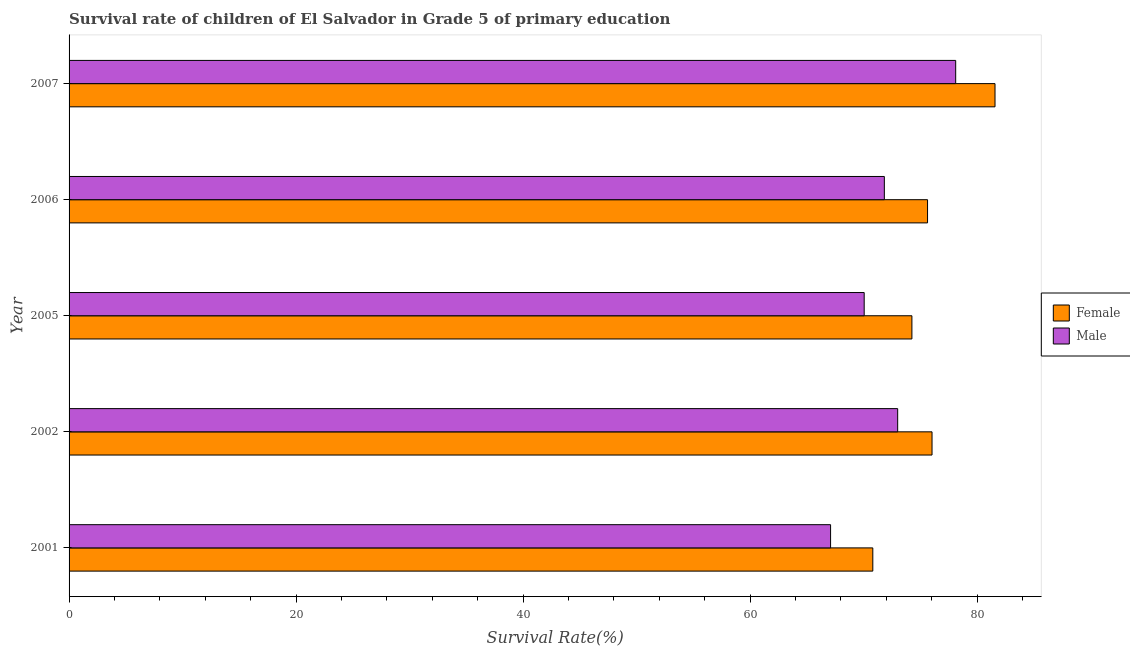How many bars are there on the 2nd tick from the bottom?
Give a very brief answer. 2. What is the label of the 5th group of bars from the top?
Ensure brevity in your answer.  2001. In how many cases, is the number of bars for a given year not equal to the number of legend labels?
Offer a very short reply. 0. What is the survival rate of female students in primary education in 2001?
Make the answer very short. 70.82. Across all years, what is the maximum survival rate of male students in primary education?
Your answer should be very brief. 78.12. Across all years, what is the minimum survival rate of female students in primary education?
Make the answer very short. 70.82. What is the total survival rate of male students in primary education in the graph?
Keep it short and to the point. 360.13. What is the difference between the survival rate of female students in primary education in 2006 and that in 2007?
Keep it short and to the point. -5.94. What is the difference between the survival rate of male students in primary education in 2002 and the survival rate of female students in primary education in 2001?
Your answer should be very brief. 2.19. What is the average survival rate of male students in primary education per year?
Provide a short and direct response. 72.03. In the year 2001, what is the difference between the survival rate of female students in primary education and survival rate of male students in primary education?
Your answer should be very brief. 3.72. In how many years, is the survival rate of female students in primary education greater than 32 %?
Provide a succinct answer. 5. Is the difference between the survival rate of male students in primary education in 2005 and 2007 greater than the difference between the survival rate of female students in primary education in 2005 and 2007?
Ensure brevity in your answer.  No. What is the difference between the highest and the second highest survival rate of female students in primary education?
Offer a very short reply. 5.55. What is the difference between the highest and the lowest survival rate of male students in primary education?
Your answer should be very brief. 11.02. Is the sum of the survival rate of female students in primary education in 2005 and 2006 greater than the maximum survival rate of male students in primary education across all years?
Your response must be concise. Yes. What does the 2nd bar from the bottom in 2007 represents?
Your answer should be very brief. Male. Are all the bars in the graph horizontal?
Provide a short and direct response. Yes. Are the values on the major ticks of X-axis written in scientific E-notation?
Keep it short and to the point. No. Does the graph contain any zero values?
Give a very brief answer. No. Where does the legend appear in the graph?
Ensure brevity in your answer.  Center right. How many legend labels are there?
Your response must be concise. 2. What is the title of the graph?
Provide a succinct answer. Survival rate of children of El Salvador in Grade 5 of primary education. Does "Electricity and heat production" appear as one of the legend labels in the graph?
Provide a short and direct response. No. What is the label or title of the X-axis?
Give a very brief answer. Survival Rate(%). What is the label or title of the Y-axis?
Your answer should be compact. Year. What is the Survival Rate(%) in Female in 2001?
Your response must be concise. 70.82. What is the Survival Rate(%) in Male in 2001?
Your answer should be compact. 67.1. What is the Survival Rate(%) of Female in 2002?
Your response must be concise. 76.04. What is the Survival Rate(%) in Male in 2002?
Your answer should be compact. 73.01. What is the Survival Rate(%) of Female in 2005?
Your answer should be very brief. 74.27. What is the Survival Rate(%) in Male in 2005?
Keep it short and to the point. 70.06. What is the Survival Rate(%) in Female in 2006?
Offer a very short reply. 75.64. What is the Survival Rate(%) of Male in 2006?
Provide a short and direct response. 71.84. What is the Survival Rate(%) of Female in 2007?
Ensure brevity in your answer.  81.59. What is the Survival Rate(%) of Male in 2007?
Offer a terse response. 78.12. Across all years, what is the maximum Survival Rate(%) of Female?
Give a very brief answer. 81.59. Across all years, what is the maximum Survival Rate(%) in Male?
Offer a terse response. 78.12. Across all years, what is the minimum Survival Rate(%) of Female?
Provide a short and direct response. 70.82. Across all years, what is the minimum Survival Rate(%) in Male?
Give a very brief answer. 67.1. What is the total Survival Rate(%) of Female in the graph?
Give a very brief answer. 378.35. What is the total Survival Rate(%) in Male in the graph?
Offer a very short reply. 360.13. What is the difference between the Survival Rate(%) in Female in 2001 and that in 2002?
Give a very brief answer. -5.22. What is the difference between the Survival Rate(%) of Male in 2001 and that in 2002?
Your response must be concise. -5.91. What is the difference between the Survival Rate(%) of Female in 2001 and that in 2005?
Offer a very short reply. -3.44. What is the difference between the Survival Rate(%) of Male in 2001 and that in 2005?
Keep it short and to the point. -2.96. What is the difference between the Survival Rate(%) of Female in 2001 and that in 2006?
Keep it short and to the point. -4.82. What is the difference between the Survival Rate(%) in Male in 2001 and that in 2006?
Provide a short and direct response. -4.74. What is the difference between the Survival Rate(%) of Female in 2001 and that in 2007?
Ensure brevity in your answer.  -10.77. What is the difference between the Survival Rate(%) of Male in 2001 and that in 2007?
Provide a succinct answer. -11.02. What is the difference between the Survival Rate(%) in Female in 2002 and that in 2005?
Offer a terse response. 1.77. What is the difference between the Survival Rate(%) in Male in 2002 and that in 2005?
Provide a short and direct response. 2.95. What is the difference between the Survival Rate(%) in Female in 2002 and that in 2006?
Keep it short and to the point. 0.39. What is the difference between the Survival Rate(%) of Male in 2002 and that in 2006?
Provide a short and direct response. 1.17. What is the difference between the Survival Rate(%) in Female in 2002 and that in 2007?
Offer a very short reply. -5.55. What is the difference between the Survival Rate(%) of Male in 2002 and that in 2007?
Make the answer very short. -5.11. What is the difference between the Survival Rate(%) in Female in 2005 and that in 2006?
Your answer should be very brief. -1.38. What is the difference between the Survival Rate(%) in Male in 2005 and that in 2006?
Give a very brief answer. -1.78. What is the difference between the Survival Rate(%) in Female in 2005 and that in 2007?
Your answer should be compact. -7.32. What is the difference between the Survival Rate(%) of Male in 2005 and that in 2007?
Keep it short and to the point. -8.06. What is the difference between the Survival Rate(%) in Female in 2006 and that in 2007?
Ensure brevity in your answer.  -5.94. What is the difference between the Survival Rate(%) in Male in 2006 and that in 2007?
Ensure brevity in your answer.  -6.29. What is the difference between the Survival Rate(%) in Female in 2001 and the Survival Rate(%) in Male in 2002?
Give a very brief answer. -2.19. What is the difference between the Survival Rate(%) in Female in 2001 and the Survival Rate(%) in Male in 2005?
Offer a terse response. 0.76. What is the difference between the Survival Rate(%) in Female in 2001 and the Survival Rate(%) in Male in 2006?
Ensure brevity in your answer.  -1.02. What is the difference between the Survival Rate(%) of Female in 2001 and the Survival Rate(%) of Male in 2007?
Offer a terse response. -7.3. What is the difference between the Survival Rate(%) in Female in 2002 and the Survival Rate(%) in Male in 2005?
Give a very brief answer. 5.98. What is the difference between the Survival Rate(%) of Female in 2002 and the Survival Rate(%) of Male in 2006?
Your response must be concise. 4.2. What is the difference between the Survival Rate(%) of Female in 2002 and the Survival Rate(%) of Male in 2007?
Offer a terse response. -2.08. What is the difference between the Survival Rate(%) of Female in 2005 and the Survival Rate(%) of Male in 2006?
Offer a very short reply. 2.43. What is the difference between the Survival Rate(%) in Female in 2005 and the Survival Rate(%) in Male in 2007?
Offer a very short reply. -3.86. What is the difference between the Survival Rate(%) of Female in 2006 and the Survival Rate(%) of Male in 2007?
Your answer should be very brief. -2.48. What is the average Survival Rate(%) in Female per year?
Provide a succinct answer. 75.67. What is the average Survival Rate(%) of Male per year?
Your answer should be very brief. 72.03. In the year 2001, what is the difference between the Survival Rate(%) of Female and Survival Rate(%) of Male?
Provide a short and direct response. 3.72. In the year 2002, what is the difference between the Survival Rate(%) of Female and Survival Rate(%) of Male?
Offer a terse response. 3.03. In the year 2005, what is the difference between the Survival Rate(%) in Female and Survival Rate(%) in Male?
Provide a succinct answer. 4.2. In the year 2006, what is the difference between the Survival Rate(%) of Female and Survival Rate(%) of Male?
Give a very brief answer. 3.81. In the year 2007, what is the difference between the Survival Rate(%) in Female and Survival Rate(%) in Male?
Offer a terse response. 3.46. What is the ratio of the Survival Rate(%) in Female in 2001 to that in 2002?
Your response must be concise. 0.93. What is the ratio of the Survival Rate(%) in Male in 2001 to that in 2002?
Provide a succinct answer. 0.92. What is the ratio of the Survival Rate(%) in Female in 2001 to that in 2005?
Make the answer very short. 0.95. What is the ratio of the Survival Rate(%) in Male in 2001 to that in 2005?
Offer a very short reply. 0.96. What is the ratio of the Survival Rate(%) in Female in 2001 to that in 2006?
Give a very brief answer. 0.94. What is the ratio of the Survival Rate(%) in Male in 2001 to that in 2006?
Your answer should be compact. 0.93. What is the ratio of the Survival Rate(%) of Female in 2001 to that in 2007?
Give a very brief answer. 0.87. What is the ratio of the Survival Rate(%) of Male in 2001 to that in 2007?
Provide a short and direct response. 0.86. What is the ratio of the Survival Rate(%) in Female in 2002 to that in 2005?
Offer a very short reply. 1.02. What is the ratio of the Survival Rate(%) of Male in 2002 to that in 2005?
Offer a very short reply. 1.04. What is the ratio of the Survival Rate(%) of Male in 2002 to that in 2006?
Give a very brief answer. 1.02. What is the ratio of the Survival Rate(%) in Female in 2002 to that in 2007?
Your answer should be very brief. 0.93. What is the ratio of the Survival Rate(%) of Male in 2002 to that in 2007?
Offer a terse response. 0.93. What is the ratio of the Survival Rate(%) of Female in 2005 to that in 2006?
Your answer should be very brief. 0.98. What is the ratio of the Survival Rate(%) in Male in 2005 to that in 2006?
Your response must be concise. 0.98. What is the ratio of the Survival Rate(%) of Female in 2005 to that in 2007?
Ensure brevity in your answer.  0.91. What is the ratio of the Survival Rate(%) in Male in 2005 to that in 2007?
Make the answer very short. 0.9. What is the ratio of the Survival Rate(%) of Female in 2006 to that in 2007?
Keep it short and to the point. 0.93. What is the ratio of the Survival Rate(%) in Male in 2006 to that in 2007?
Make the answer very short. 0.92. What is the difference between the highest and the second highest Survival Rate(%) of Female?
Your answer should be compact. 5.55. What is the difference between the highest and the second highest Survival Rate(%) in Male?
Make the answer very short. 5.11. What is the difference between the highest and the lowest Survival Rate(%) in Female?
Ensure brevity in your answer.  10.77. What is the difference between the highest and the lowest Survival Rate(%) in Male?
Offer a very short reply. 11.02. 